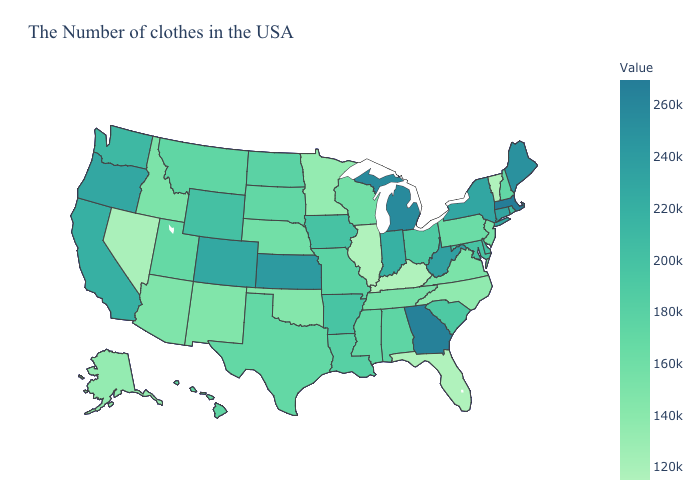Which states hav the highest value in the MidWest?
Concise answer only. Michigan. Which states have the lowest value in the South?
Give a very brief answer. Florida, Kentucky. Which states hav the highest value in the West?
Short answer required. Oregon. Does New York have the highest value in the Northeast?
Short answer required. No. 